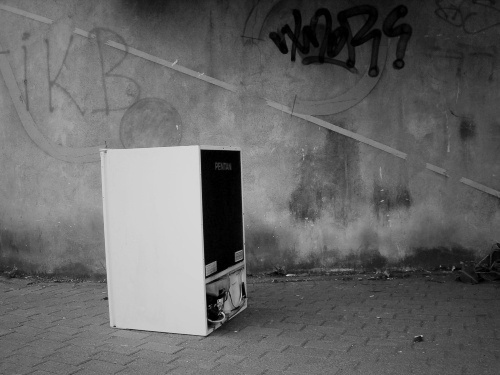Describe the objects in this image and their specific colors. I can see a refrigerator in gray, lightgray, black, and darkgray tones in this image. 